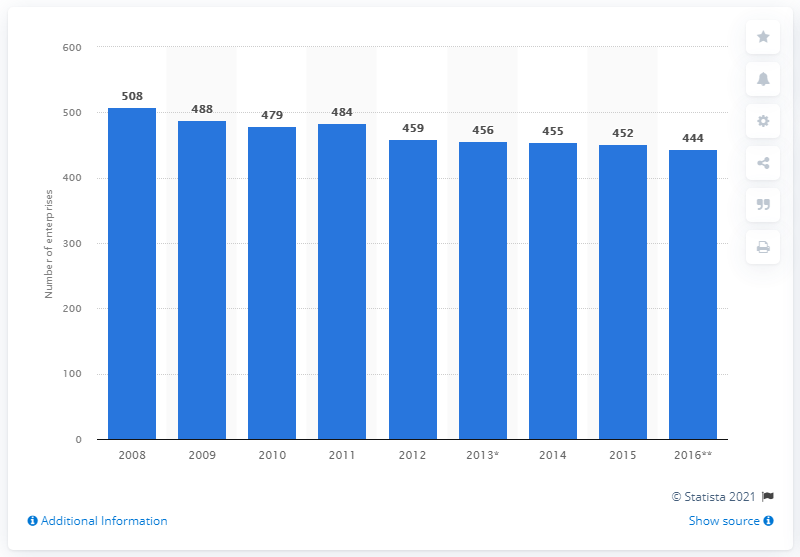Identify some key points in this picture. In 2015, there were 452 enterprises in Finland that manufactured medical and dental instruments and supplies. 